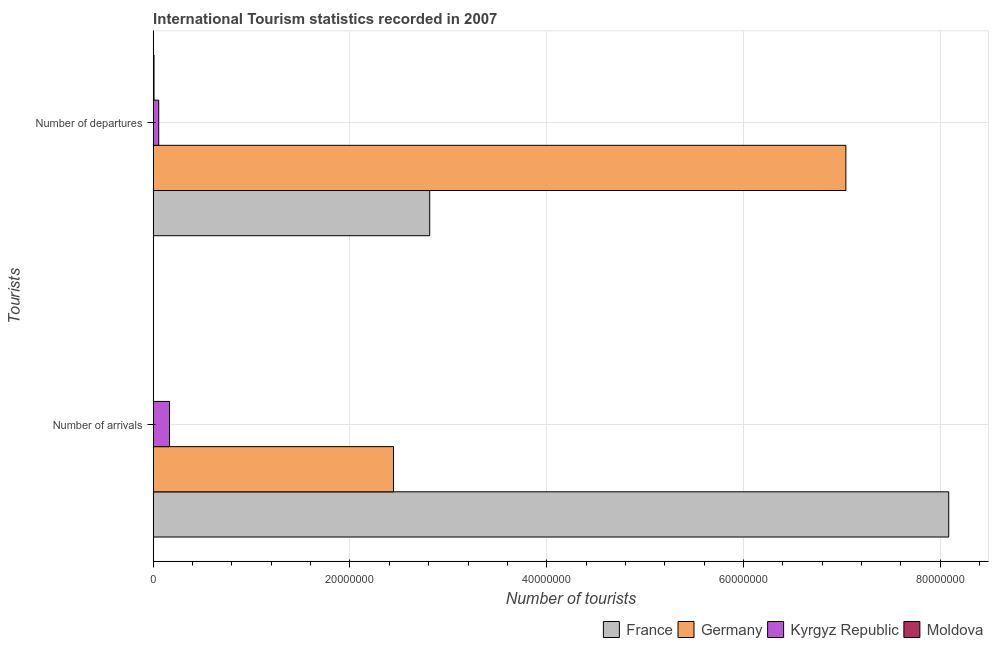Are the number of bars on each tick of the Y-axis equal?
Make the answer very short. Yes. How many bars are there on the 2nd tick from the bottom?
Offer a very short reply. 4. What is the label of the 2nd group of bars from the top?
Your response must be concise. Number of arrivals. What is the number of tourist arrivals in France?
Provide a short and direct response. 8.09e+07. Across all countries, what is the maximum number of tourist departures?
Offer a terse response. 7.04e+07. Across all countries, what is the minimum number of tourist arrivals?
Offer a very short reply. 1.30e+04. In which country was the number of tourist arrivals minimum?
Make the answer very short. Moldova. What is the total number of tourist departures in the graph?
Your answer should be compact. 9.91e+07. What is the difference between the number of tourist departures in France and that in Germany?
Your response must be concise. -4.23e+07. What is the difference between the number of tourist departures in Germany and the number of tourist arrivals in France?
Your response must be concise. -1.05e+07. What is the average number of tourist departures per country?
Keep it short and to the point. 2.48e+07. What is the difference between the number of tourist arrivals and number of tourist departures in Germany?
Ensure brevity in your answer.  -4.60e+07. What is the ratio of the number of tourist departures in France to that in Germany?
Your answer should be very brief. 0.4. In how many countries, is the number of tourist arrivals greater than the average number of tourist arrivals taken over all countries?
Offer a terse response. 1. What does the 3rd bar from the top in Number of departures represents?
Make the answer very short. Germany. What does the 4th bar from the bottom in Number of arrivals represents?
Keep it short and to the point. Moldova. How many bars are there?
Make the answer very short. 8. How many countries are there in the graph?
Ensure brevity in your answer.  4. Does the graph contain any zero values?
Give a very brief answer. No. Does the graph contain grids?
Provide a short and direct response. Yes. Where does the legend appear in the graph?
Provide a succinct answer. Bottom right. How many legend labels are there?
Your answer should be very brief. 4. What is the title of the graph?
Provide a succinct answer. International Tourism statistics recorded in 2007. What is the label or title of the X-axis?
Give a very brief answer. Number of tourists. What is the label or title of the Y-axis?
Your answer should be compact. Tourists. What is the Number of tourists of France in Number of arrivals?
Provide a short and direct response. 8.09e+07. What is the Number of tourists in Germany in Number of arrivals?
Your response must be concise. 2.44e+07. What is the Number of tourists of Kyrgyz Republic in Number of arrivals?
Your answer should be very brief. 1.66e+06. What is the Number of tourists of Moldova in Number of arrivals?
Keep it short and to the point. 1.30e+04. What is the Number of tourists of France in Number of departures?
Offer a very short reply. 2.81e+07. What is the Number of tourists of Germany in Number of departures?
Your answer should be compact. 7.04e+07. What is the Number of tourists of Kyrgyz Republic in Number of departures?
Your response must be concise. 5.59e+05. What is the Number of tourists of Moldova in Number of departures?
Your answer should be very brief. 8.20e+04. Across all Tourists, what is the maximum Number of tourists in France?
Your answer should be compact. 8.09e+07. Across all Tourists, what is the maximum Number of tourists in Germany?
Your answer should be compact. 7.04e+07. Across all Tourists, what is the maximum Number of tourists in Kyrgyz Republic?
Keep it short and to the point. 1.66e+06. Across all Tourists, what is the maximum Number of tourists of Moldova?
Offer a terse response. 8.20e+04. Across all Tourists, what is the minimum Number of tourists in France?
Ensure brevity in your answer.  2.81e+07. Across all Tourists, what is the minimum Number of tourists of Germany?
Offer a terse response. 2.44e+07. Across all Tourists, what is the minimum Number of tourists in Kyrgyz Republic?
Make the answer very short. 5.59e+05. Across all Tourists, what is the minimum Number of tourists of Moldova?
Offer a terse response. 1.30e+04. What is the total Number of tourists of France in the graph?
Your answer should be compact. 1.09e+08. What is the total Number of tourists of Germany in the graph?
Your answer should be very brief. 9.48e+07. What is the total Number of tourists in Kyrgyz Republic in the graph?
Make the answer very short. 2.22e+06. What is the total Number of tourists in Moldova in the graph?
Give a very brief answer. 9.50e+04. What is the difference between the Number of tourists of France in Number of arrivals and that in Number of departures?
Your answer should be compact. 5.28e+07. What is the difference between the Number of tourists in Germany in Number of arrivals and that in Number of departures?
Your answer should be very brief. -4.60e+07. What is the difference between the Number of tourists of Kyrgyz Republic in Number of arrivals and that in Number of departures?
Your response must be concise. 1.10e+06. What is the difference between the Number of tourists of Moldova in Number of arrivals and that in Number of departures?
Keep it short and to the point. -6.90e+04. What is the difference between the Number of tourists of France in Number of arrivals and the Number of tourists of Germany in Number of departures?
Offer a very short reply. 1.05e+07. What is the difference between the Number of tourists in France in Number of arrivals and the Number of tourists in Kyrgyz Republic in Number of departures?
Provide a succinct answer. 8.03e+07. What is the difference between the Number of tourists of France in Number of arrivals and the Number of tourists of Moldova in Number of departures?
Your answer should be compact. 8.08e+07. What is the difference between the Number of tourists of Germany in Number of arrivals and the Number of tourists of Kyrgyz Republic in Number of departures?
Offer a terse response. 2.39e+07. What is the difference between the Number of tourists of Germany in Number of arrivals and the Number of tourists of Moldova in Number of departures?
Your answer should be compact. 2.43e+07. What is the difference between the Number of tourists of Kyrgyz Republic in Number of arrivals and the Number of tourists of Moldova in Number of departures?
Your answer should be compact. 1.57e+06. What is the average Number of tourists of France per Tourists?
Offer a very short reply. 5.45e+07. What is the average Number of tourists in Germany per Tourists?
Offer a terse response. 4.74e+07. What is the average Number of tourists of Kyrgyz Republic per Tourists?
Keep it short and to the point. 1.11e+06. What is the average Number of tourists in Moldova per Tourists?
Ensure brevity in your answer.  4.75e+04. What is the difference between the Number of tourists of France and Number of tourists of Germany in Number of arrivals?
Your response must be concise. 5.64e+07. What is the difference between the Number of tourists in France and Number of tourists in Kyrgyz Republic in Number of arrivals?
Ensure brevity in your answer.  7.92e+07. What is the difference between the Number of tourists of France and Number of tourists of Moldova in Number of arrivals?
Provide a succinct answer. 8.08e+07. What is the difference between the Number of tourists of Germany and Number of tourists of Kyrgyz Republic in Number of arrivals?
Offer a terse response. 2.28e+07. What is the difference between the Number of tourists of Germany and Number of tourists of Moldova in Number of arrivals?
Give a very brief answer. 2.44e+07. What is the difference between the Number of tourists of Kyrgyz Republic and Number of tourists of Moldova in Number of arrivals?
Offer a terse response. 1.64e+06. What is the difference between the Number of tourists in France and Number of tourists in Germany in Number of departures?
Give a very brief answer. -4.23e+07. What is the difference between the Number of tourists of France and Number of tourists of Kyrgyz Republic in Number of departures?
Your answer should be compact. 2.75e+07. What is the difference between the Number of tourists in France and Number of tourists in Moldova in Number of departures?
Your answer should be very brief. 2.80e+07. What is the difference between the Number of tourists in Germany and Number of tourists in Kyrgyz Republic in Number of departures?
Give a very brief answer. 6.98e+07. What is the difference between the Number of tourists of Germany and Number of tourists of Moldova in Number of departures?
Your answer should be very brief. 7.03e+07. What is the difference between the Number of tourists in Kyrgyz Republic and Number of tourists in Moldova in Number of departures?
Your response must be concise. 4.77e+05. What is the ratio of the Number of tourists of France in Number of arrivals to that in Number of departures?
Give a very brief answer. 2.88. What is the ratio of the Number of tourists in Germany in Number of arrivals to that in Number of departures?
Your response must be concise. 0.35. What is the ratio of the Number of tourists of Kyrgyz Republic in Number of arrivals to that in Number of departures?
Keep it short and to the point. 2.96. What is the ratio of the Number of tourists in Moldova in Number of arrivals to that in Number of departures?
Your answer should be very brief. 0.16. What is the difference between the highest and the second highest Number of tourists in France?
Ensure brevity in your answer.  5.28e+07. What is the difference between the highest and the second highest Number of tourists in Germany?
Offer a terse response. 4.60e+07. What is the difference between the highest and the second highest Number of tourists in Kyrgyz Republic?
Offer a terse response. 1.10e+06. What is the difference between the highest and the second highest Number of tourists of Moldova?
Ensure brevity in your answer.  6.90e+04. What is the difference between the highest and the lowest Number of tourists in France?
Make the answer very short. 5.28e+07. What is the difference between the highest and the lowest Number of tourists in Germany?
Give a very brief answer. 4.60e+07. What is the difference between the highest and the lowest Number of tourists in Kyrgyz Republic?
Offer a very short reply. 1.10e+06. What is the difference between the highest and the lowest Number of tourists of Moldova?
Make the answer very short. 6.90e+04. 